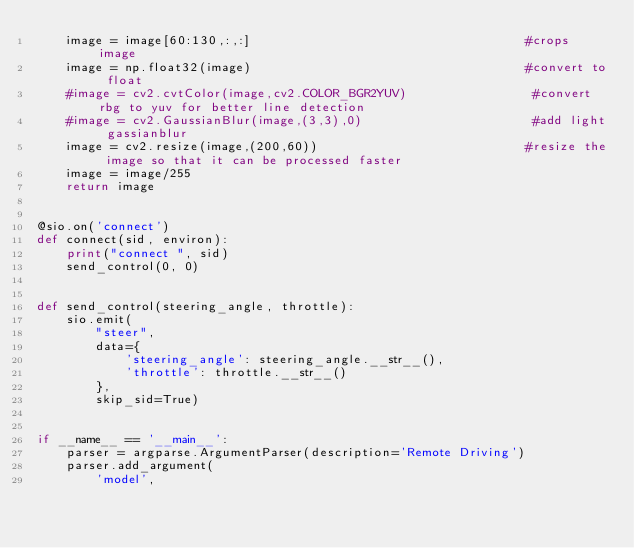<code> <loc_0><loc_0><loc_500><loc_500><_Python_>    image = image[60:130,:,:]                                     #crops image
    image = np.float32(image)                                     #convert to float
    #image = cv2.cvtColor(image,cv2.COLOR_BGR2YUV)                 #convert rbg to yuv for better line detection
    #image = cv2.GaussianBlur(image,(3,3),0)                       #add light gassianblur
    image = cv2.resize(image,(200,60))                            #resize the image so that it can be processed faster
    image = image/255
    return image
    

@sio.on('connect')
def connect(sid, environ):
    print("connect ", sid)
    send_control(0, 0)


def send_control(steering_angle, throttle):
    sio.emit(
        "steer",
        data={
            'steering_angle': steering_angle.__str__(),
            'throttle': throttle.__str__()
        },
        skip_sid=True)


if __name__ == '__main__':
    parser = argparse.ArgumentParser(description='Remote Driving')
    parser.add_argument(
        'model',</code> 